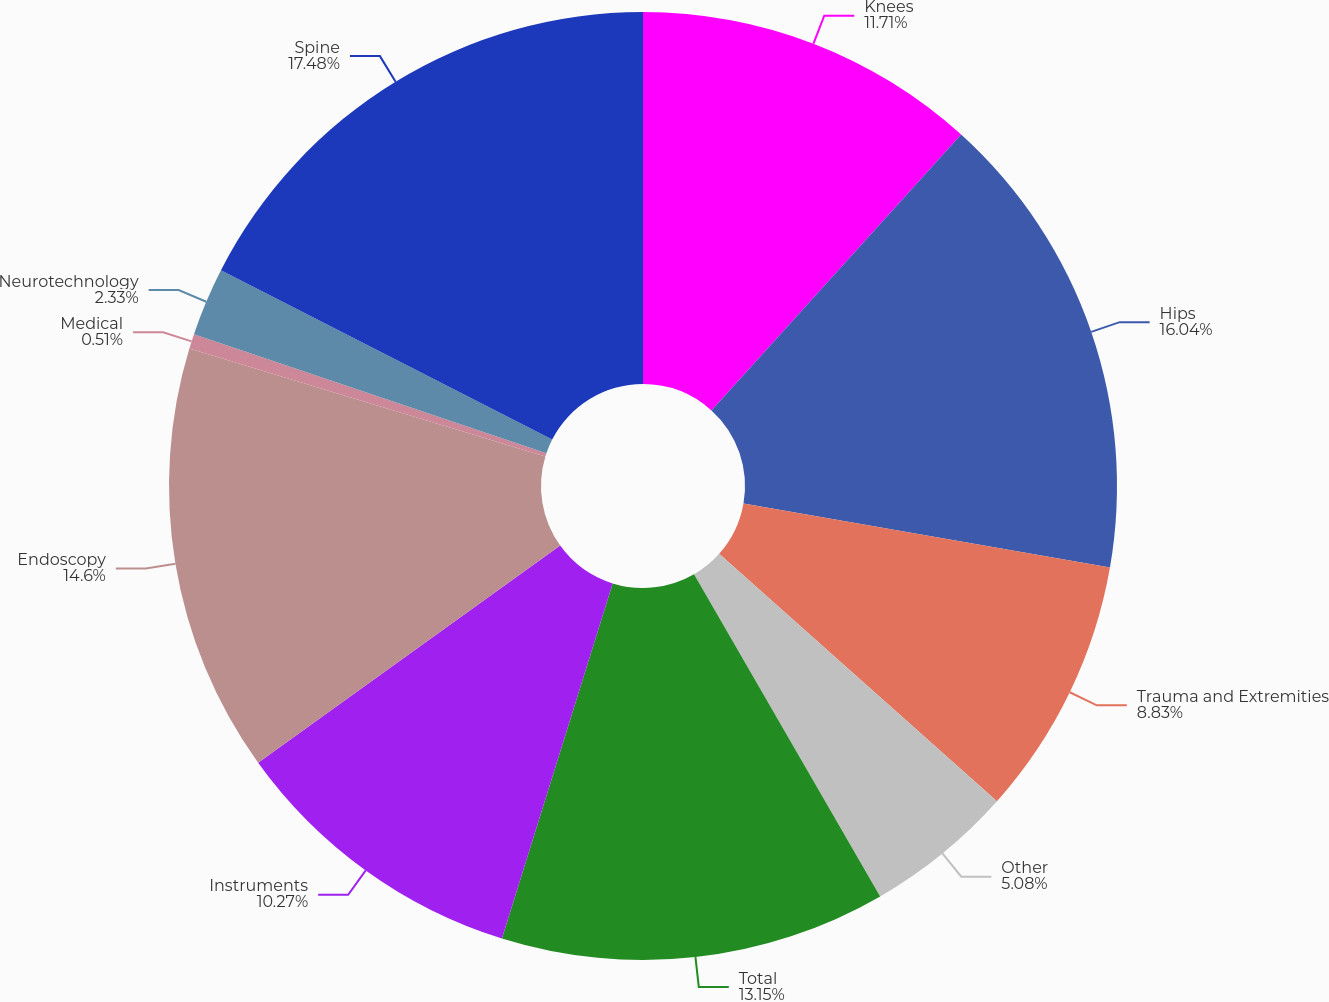Convert chart to OTSL. <chart><loc_0><loc_0><loc_500><loc_500><pie_chart><fcel>Knees<fcel>Hips<fcel>Trauma and Extremities<fcel>Other<fcel>Total<fcel>Instruments<fcel>Endoscopy<fcel>Medical<fcel>Neurotechnology<fcel>Spine<nl><fcel>11.71%<fcel>16.04%<fcel>8.83%<fcel>5.08%<fcel>13.15%<fcel>10.27%<fcel>14.6%<fcel>0.51%<fcel>2.33%<fcel>17.48%<nl></chart> 